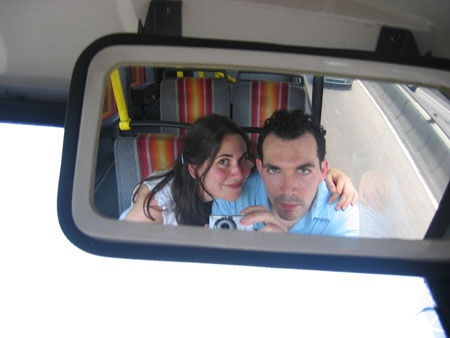Describe the objects in this image and their specific colors. I can see people in gray, darkgray, black, and lightblue tones, people in gray, black, and darkgray tones, and car in gray and darkgray tones in this image. 